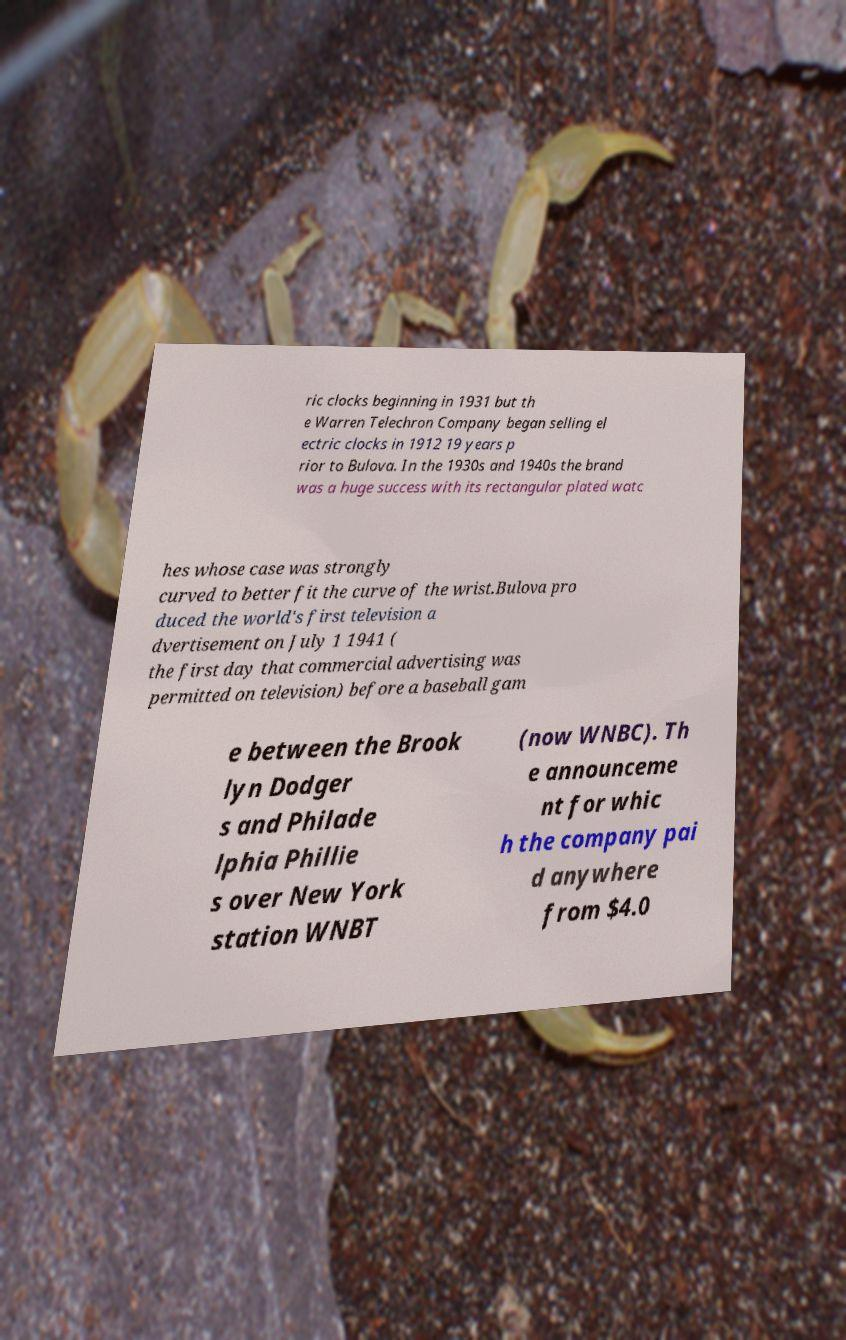Can you read and provide the text displayed in the image?This photo seems to have some interesting text. Can you extract and type it out for me? ric clocks beginning in 1931 but th e Warren Telechron Company began selling el ectric clocks in 1912 19 years p rior to Bulova. In the 1930s and 1940s the brand was a huge success with its rectangular plated watc hes whose case was strongly curved to better fit the curve of the wrist.Bulova pro duced the world's first television a dvertisement on July 1 1941 ( the first day that commercial advertising was permitted on television) before a baseball gam e between the Brook lyn Dodger s and Philade lphia Phillie s over New York station WNBT (now WNBC). Th e announceme nt for whic h the company pai d anywhere from $4.0 